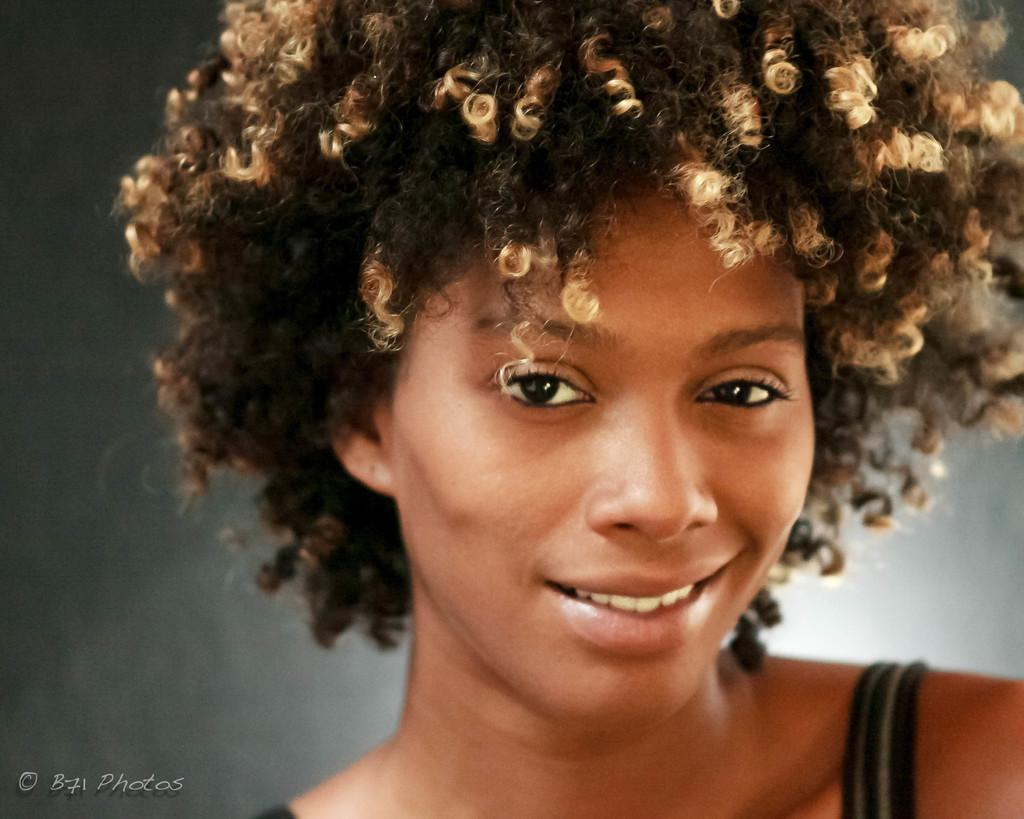What is the main subject of the image? There is a person in the image. Can you describe any text present in the image? Yes, there is text in the bottom left of the image. Is there a bed in the image? No, there is no bed present in the image. What type of hope is depicted in the image? There is no depiction of hope in the image; it only features a person and text. 